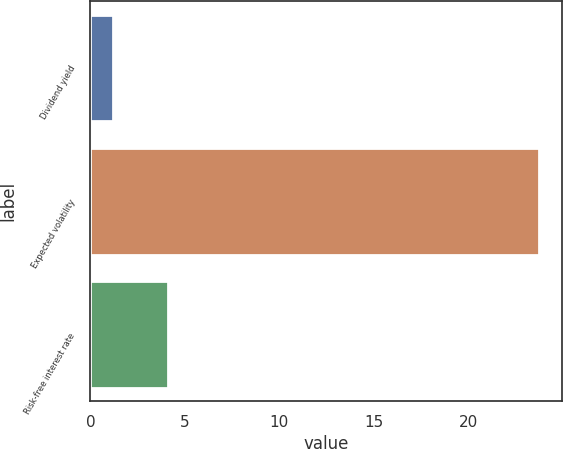<chart> <loc_0><loc_0><loc_500><loc_500><bar_chart><fcel>Dividend yield<fcel>Expected volatility<fcel>Risk-free interest rate<nl><fcel>1.2<fcel>23.77<fcel>4.13<nl></chart> 